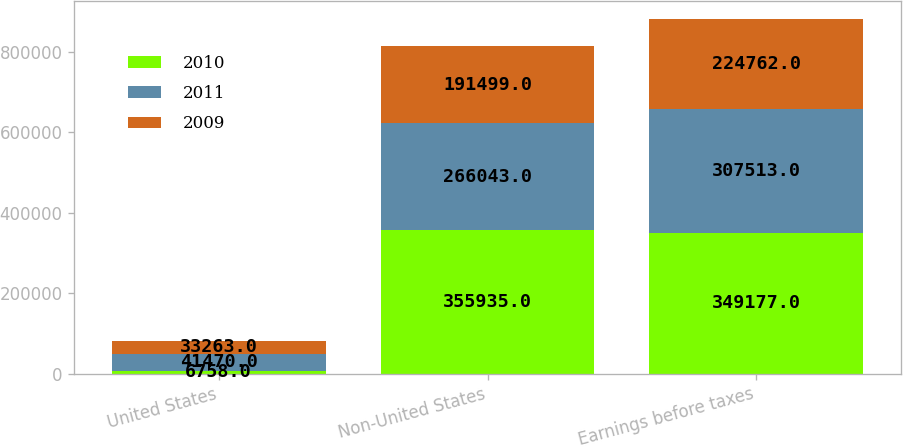<chart> <loc_0><loc_0><loc_500><loc_500><stacked_bar_chart><ecel><fcel>United States<fcel>Non-United States<fcel>Earnings before taxes<nl><fcel>2010<fcel>6758<fcel>355935<fcel>349177<nl><fcel>2011<fcel>41470<fcel>266043<fcel>307513<nl><fcel>2009<fcel>33263<fcel>191499<fcel>224762<nl></chart> 